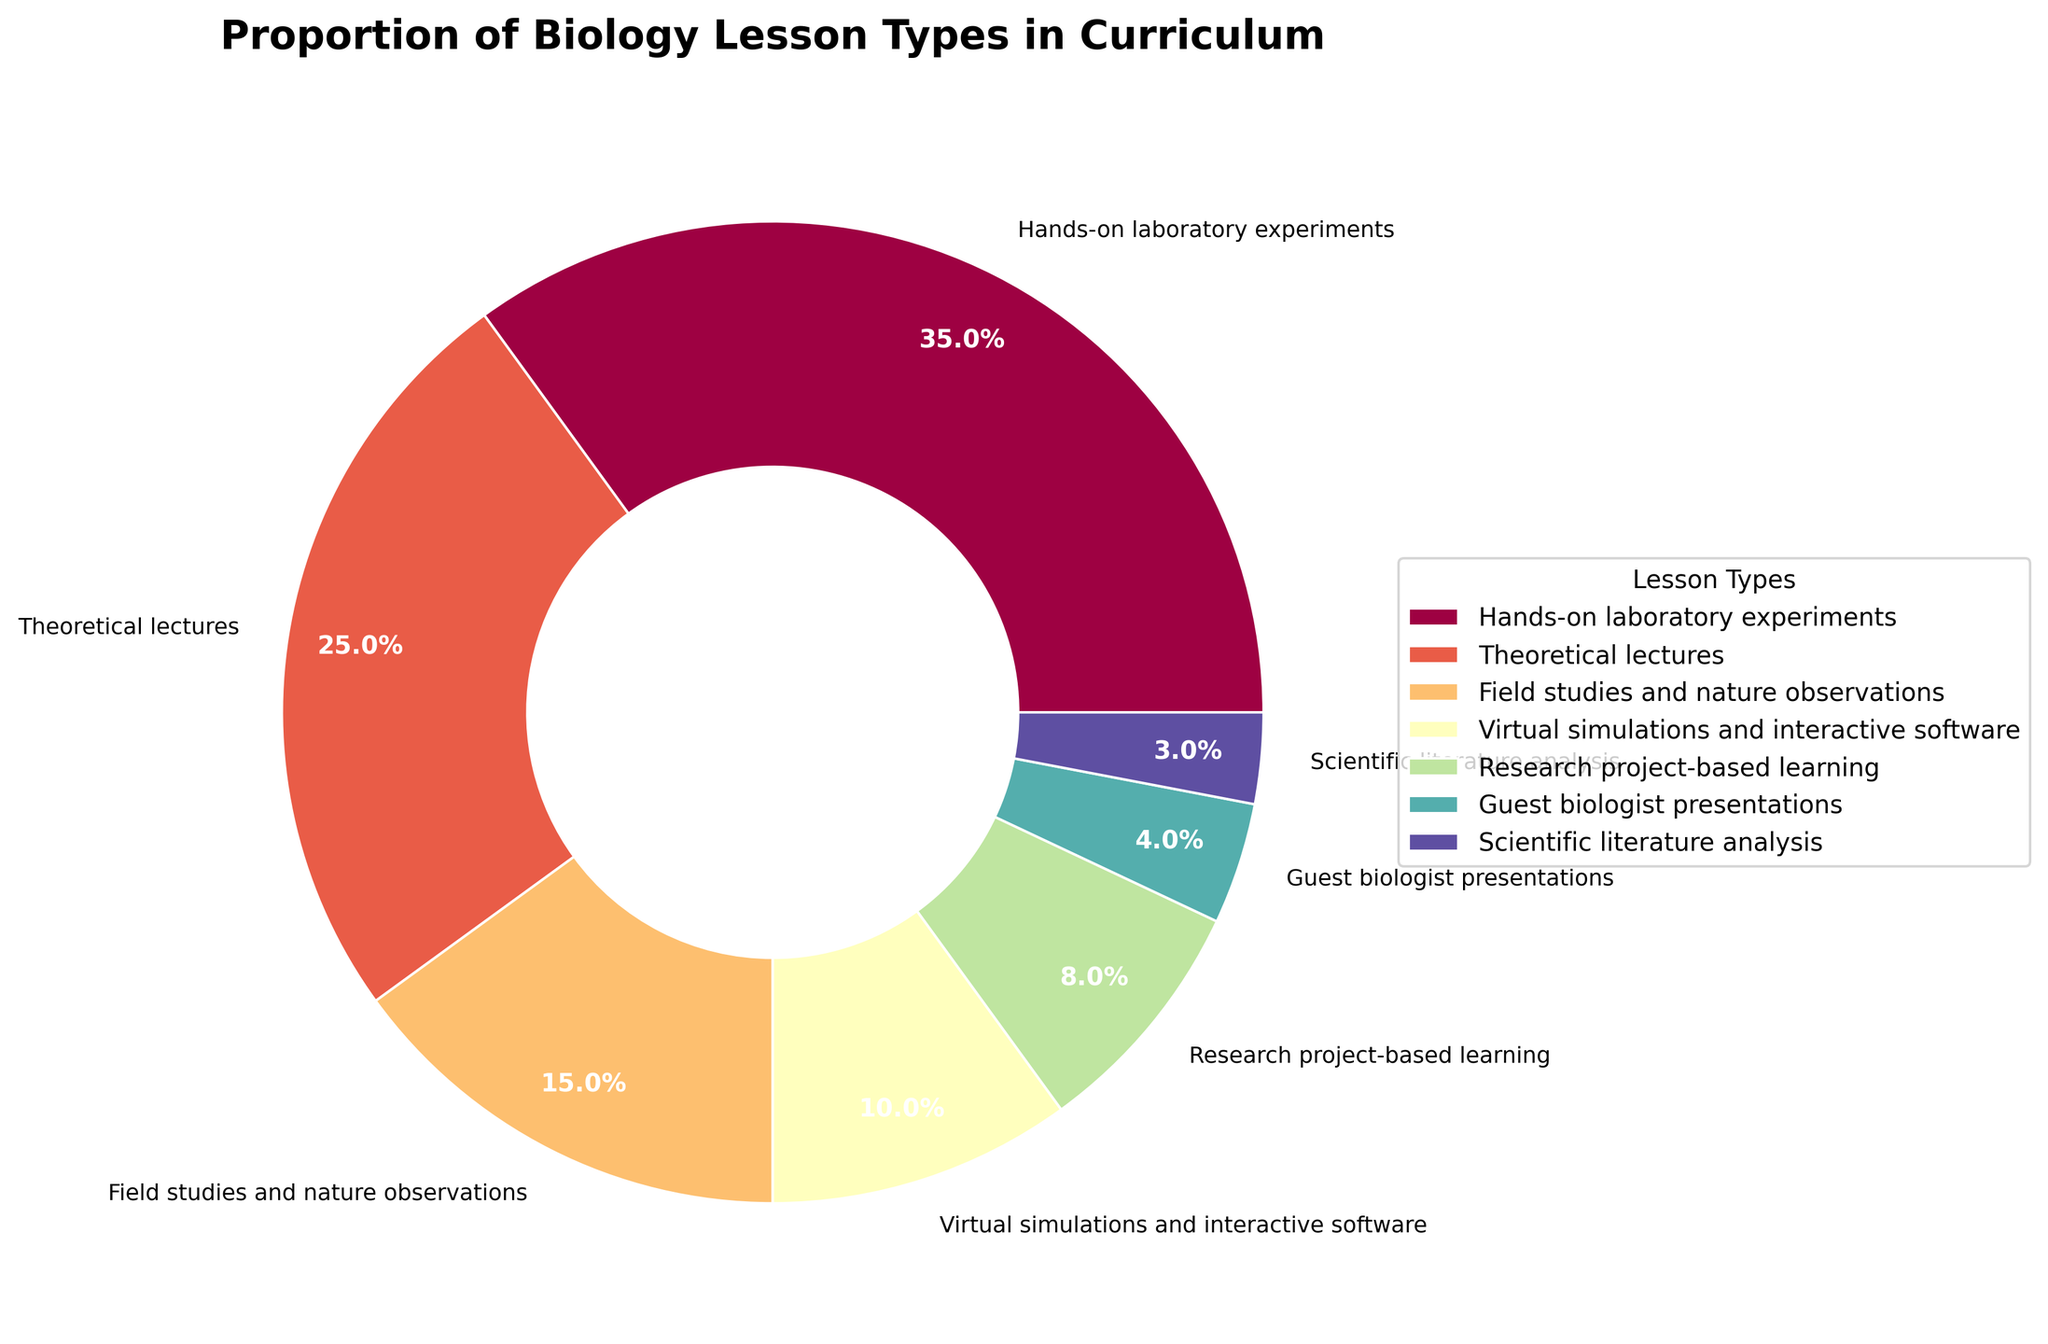What is the percentage of hands-on laboratory experiments in the curriculum? The wedge labeled "Hands-on laboratory experiments" shows 35%, indicating that 35% of the curriculum is dedicated to hands-on laboratory experiments.
Answer: 35% What is the combined percentage of hands-on laboratory experiments and theoretical lectures? The figure shows that hands-on laboratory experiments constitute 35% and theoretical lectures constitute 25%. Adding these together: 35% + 25% = 60%.
Answer: 60% Which type of lesson constitutes the smallest percentage in the curriculum? The pie chart shows that "Scientific literature analysis" has a wedge representing 3%, which is the smallest proportion among all lesson types.
Answer: Scientific literature analysis How much greater is the percentage of hands-on laboratory experiments compared to guest biologist presentations? The percentage for hands-on laboratory experiments is 35%, and for guest biologist presentations, it is 4%. The difference is 35% - 4% = 31%.
Answer: 31% What proportion of the curriculum is dedicated to both virtual simulations and guest biologist presentations combined? Virtual simulations are allocated 10% and guest biologist presentations 4%. Combined, they make up 10% + 4% = 14% of the curriculum.
Answer: 14% Are theoretical lectures more than virtual simulations by more than twice their percentage? Theoretical lectures constitute 25% and virtual simulations 10%. Twice the percentage of virtual simulations is 2 * 10% = 20%. Since 25% is greater than 20%, theoretical lectures are more than twice the percentage of virtual simulations.
Answer: Yes Which two lesson types together form exactly half of the biology curriculum by percentage? Hands-on laboratory experiments make up 35% and field studies and nature observations make up 15%. Together, they total 35% + 15% = 50%, which is half of the curriculum.
Answer: Hands-on laboratory experiments and field studies and nature observations What is the summed percentage of lessons that are either theoretical or involve nature observations? The theoretical lectures are 25% and field studies and nature observations are 15%. Summed together, 25% + 15% = 40%.
Answer: 40% Among all the lesson types, how many types contribute to less than 10% individually? According to the chart, "Guest biologist presentations" (4%), "Scientific literature analysis" (3%), and "Research project-based learning" (8%) are less than 10%. That makes 3 types.
Answer: 3 